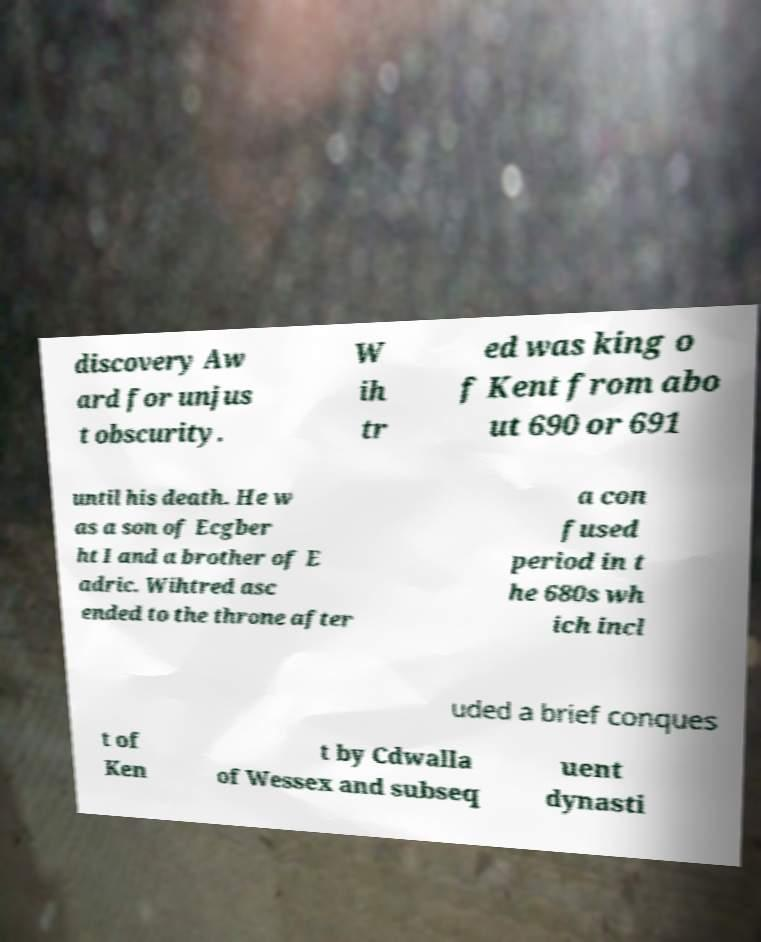There's text embedded in this image that I need extracted. Can you transcribe it verbatim? discovery Aw ard for unjus t obscurity. W ih tr ed was king o f Kent from abo ut 690 or 691 until his death. He w as a son of Ecgber ht I and a brother of E adric. Wihtred asc ended to the throne after a con fused period in t he 680s wh ich incl uded a brief conques t of Ken t by Cdwalla of Wessex and subseq uent dynasti 